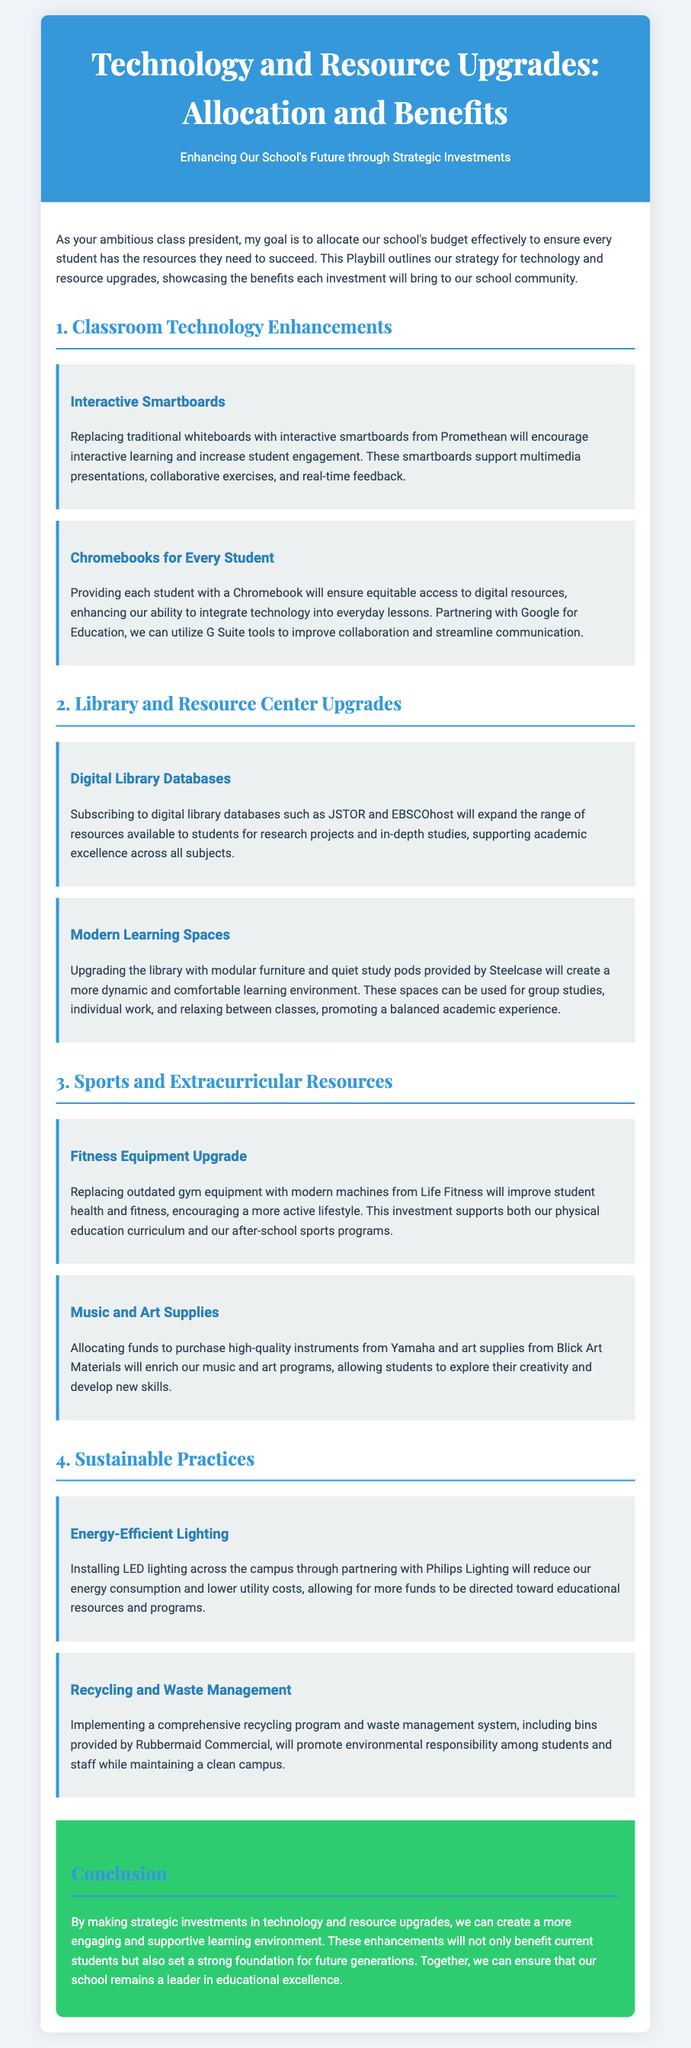What technology is proposed for classroom enhancements? The document lists interactive smartboards and Chromebooks as proposed technology for classroom enhancements.
Answer: Interactive smartboards and Chromebooks How much will be enhanced for library resource availability? Subscribing to digital library databases will expand the range of resources available for research projects and in-depth studies.
Answer: Digital library databases What type of items will be upgraded for sports resources? The document mentions replacing outdated gym equipment as a key upgrade in sports resources.
Answer: Gym equipment Who is the supplier for modern learning spaces in the library? The document specifies that Steelcase will provide modular furniture and quiet study pods for library upgrades.
Answer: Steelcase What is a benefit of installing energy-efficient lighting? The document states that installing LED lighting will reduce energy consumption and lower utility costs.
Answer: Reduce energy consumption Which company is involved in the recycling and waste management program? The recycling program includes bins provided by Rubbermaid Commercial.
Answer: Rubbermaid Commercial What is the purpose of enhancing fitness equipment? Enhancing fitness equipment is intended to improve student health and fitness while encouraging a more active lifestyle.
Answer: Improve student health and fitness What is the conclusion about the strategic investments made? The conclusion states that these enhancements will benefit current students and set a strong foundation for future generations.
Answer: Benefit current students and future generations 